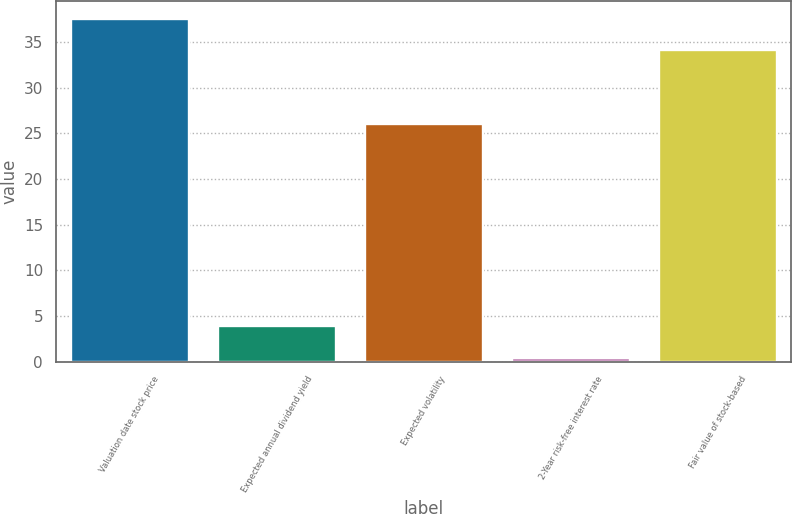<chart> <loc_0><loc_0><loc_500><loc_500><bar_chart><fcel>Valuation date stock price<fcel>Expected annual dividend yield<fcel>Expected volatility<fcel>2-Year risk-free interest rate<fcel>Fair value of stock-based<nl><fcel>37.57<fcel>3.89<fcel>26<fcel>0.4<fcel>34.08<nl></chart> 